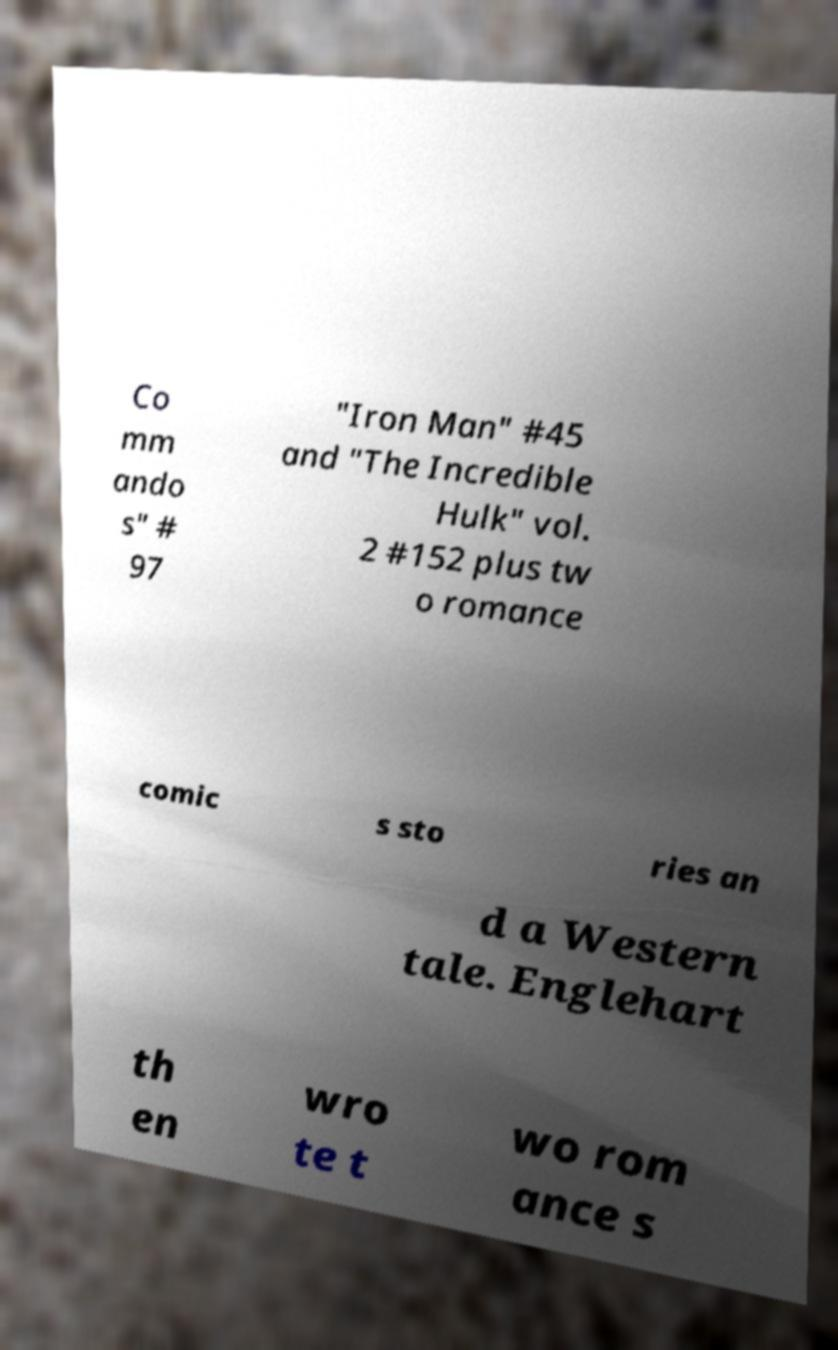I need the written content from this picture converted into text. Can you do that? Co mm ando s" # 97 "Iron Man" #45 and "The Incredible Hulk" vol. 2 #152 plus tw o romance comic s sto ries an d a Western tale. Englehart th en wro te t wo rom ance s 